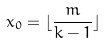Convert formula to latex. <formula><loc_0><loc_0><loc_500><loc_500>x _ { 0 } = \lfloor \frac { m } { k - 1 } \rfloor</formula> 